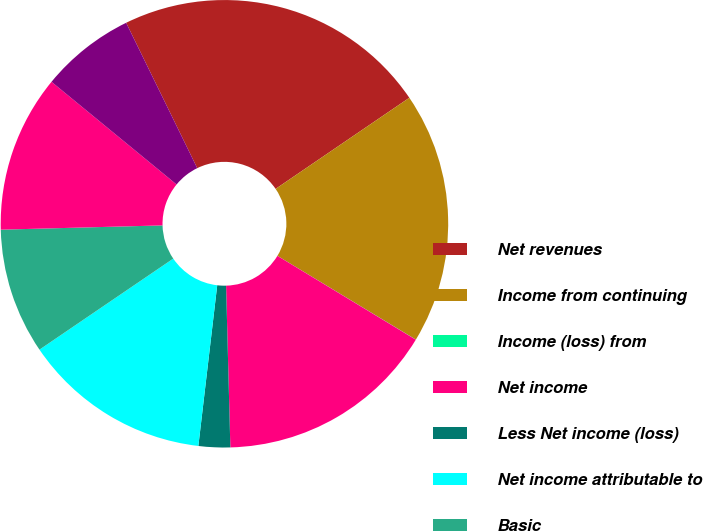<chart> <loc_0><loc_0><loc_500><loc_500><pie_chart><fcel>Net revenues<fcel>Income from continuing<fcel>Income (loss) from<fcel>Net income<fcel>Less Net income (loss)<fcel>Net income attributable to<fcel>Basic<fcel>Diluted<fcel>High<nl><fcel>22.72%<fcel>18.18%<fcel>0.01%<fcel>15.91%<fcel>2.28%<fcel>13.63%<fcel>9.09%<fcel>11.36%<fcel>6.82%<nl></chart> 